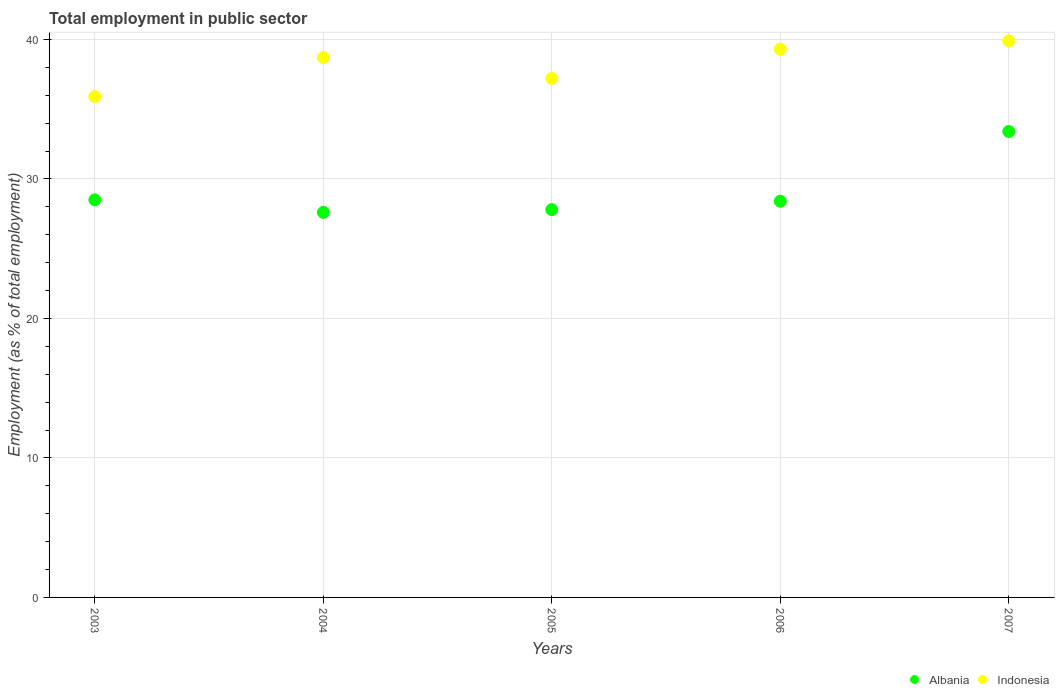What is the employment in public sector in Albania in 2003?
Provide a succinct answer. 28.5. Across all years, what is the maximum employment in public sector in Albania?
Your response must be concise. 33.4. Across all years, what is the minimum employment in public sector in Albania?
Your answer should be compact. 27.6. In which year was the employment in public sector in Albania maximum?
Provide a short and direct response. 2007. In which year was the employment in public sector in Albania minimum?
Provide a short and direct response. 2004. What is the total employment in public sector in Albania in the graph?
Offer a very short reply. 145.7. What is the difference between the employment in public sector in Albania in 2004 and that in 2006?
Make the answer very short. -0.8. What is the difference between the employment in public sector in Indonesia in 2003 and the employment in public sector in Albania in 2005?
Your response must be concise. 8.1. What is the average employment in public sector in Indonesia per year?
Make the answer very short. 38.2. In the year 2003, what is the difference between the employment in public sector in Albania and employment in public sector in Indonesia?
Your response must be concise. -7.4. In how many years, is the employment in public sector in Indonesia greater than 18 %?
Your answer should be very brief. 5. What is the ratio of the employment in public sector in Albania in 2005 to that in 2006?
Offer a very short reply. 0.98. Is the employment in public sector in Albania in 2004 less than that in 2005?
Make the answer very short. Yes. What is the difference between the highest and the second highest employment in public sector in Albania?
Offer a very short reply. 4.9. Does the employment in public sector in Indonesia monotonically increase over the years?
Your answer should be very brief. No. Is the employment in public sector in Albania strictly greater than the employment in public sector in Indonesia over the years?
Provide a succinct answer. No. Is the employment in public sector in Indonesia strictly less than the employment in public sector in Albania over the years?
Your answer should be very brief. No. How many dotlines are there?
Offer a very short reply. 2. How many years are there in the graph?
Provide a succinct answer. 5. Does the graph contain any zero values?
Keep it short and to the point. No. How many legend labels are there?
Make the answer very short. 2. What is the title of the graph?
Offer a very short reply. Total employment in public sector. Does "Least developed countries" appear as one of the legend labels in the graph?
Offer a terse response. No. What is the label or title of the Y-axis?
Your answer should be very brief. Employment (as % of total employment). What is the Employment (as % of total employment) in Indonesia in 2003?
Offer a terse response. 35.9. What is the Employment (as % of total employment) of Albania in 2004?
Your response must be concise. 27.6. What is the Employment (as % of total employment) in Indonesia in 2004?
Provide a succinct answer. 38.7. What is the Employment (as % of total employment) in Albania in 2005?
Offer a terse response. 27.8. What is the Employment (as % of total employment) in Indonesia in 2005?
Keep it short and to the point. 37.2. What is the Employment (as % of total employment) in Albania in 2006?
Your response must be concise. 28.4. What is the Employment (as % of total employment) in Indonesia in 2006?
Offer a very short reply. 39.3. What is the Employment (as % of total employment) in Albania in 2007?
Provide a short and direct response. 33.4. What is the Employment (as % of total employment) in Indonesia in 2007?
Keep it short and to the point. 39.9. Across all years, what is the maximum Employment (as % of total employment) in Albania?
Keep it short and to the point. 33.4. Across all years, what is the maximum Employment (as % of total employment) in Indonesia?
Make the answer very short. 39.9. Across all years, what is the minimum Employment (as % of total employment) of Albania?
Keep it short and to the point. 27.6. Across all years, what is the minimum Employment (as % of total employment) of Indonesia?
Offer a very short reply. 35.9. What is the total Employment (as % of total employment) in Albania in the graph?
Provide a short and direct response. 145.7. What is the total Employment (as % of total employment) of Indonesia in the graph?
Your answer should be compact. 191. What is the difference between the Employment (as % of total employment) in Albania in 2003 and that in 2004?
Provide a succinct answer. 0.9. What is the difference between the Employment (as % of total employment) of Albania in 2003 and that in 2005?
Your answer should be very brief. 0.7. What is the difference between the Employment (as % of total employment) in Albania in 2003 and that in 2006?
Provide a short and direct response. 0.1. What is the difference between the Employment (as % of total employment) of Indonesia in 2003 and that in 2006?
Offer a terse response. -3.4. What is the difference between the Employment (as % of total employment) of Albania in 2003 and that in 2007?
Offer a very short reply. -4.9. What is the difference between the Employment (as % of total employment) of Indonesia in 2003 and that in 2007?
Offer a very short reply. -4. What is the difference between the Employment (as % of total employment) of Indonesia in 2004 and that in 2005?
Provide a succinct answer. 1.5. What is the difference between the Employment (as % of total employment) in Albania in 2004 and that in 2006?
Make the answer very short. -0.8. What is the difference between the Employment (as % of total employment) in Indonesia in 2004 and that in 2007?
Provide a succinct answer. -1.2. What is the difference between the Employment (as % of total employment) in Albania in 2005 and that in 2006?
Provide a succinct answer. -0.6. What is the difference between the Employment (as % of total employment) in Indonesia in 2005 and that in 2006?
Make the answer very short. -2.1. What is the difference between the Employment (as % of total employment) in Albania in 2005 and that in 2007?
Provide a succinct answer. -5.6. What is the difference between the Employment (as % of total employment) in Indonesia in 2005 and that in 2007?
Provide a succinct answer. -2.7. What is the difference between the Employment (as % of total employment) of Albania in 2006 and that in 2007?
Your answer should be compact. -5. What is the difference between the Employment (as % of total employment) in Indonesia in 2006 and that in 2007?
Give a very brief answer. -0.6. What is the difference between the Employment (as % of total employment) in Albania in 2003 and the Employment (as % of total employment) in Indonesia in 2005?
Keep it short and to the point. -8.7. What is the difference between the Employment (as % of total employment) in Albania in 2003 and the Employment (as % of total employment) in Indonesia in 2006?
Your answer should be very brief. -10.8. What is the difference between the Employment (as % of total employment) in Albania in 2003 and the Employment (as % of total employment) in Indonesia in 2007?
Your answer should be very brief. -11.4. What is the difference between the Employment (as % of total employment) in Albania in 2004 and the Employment (as % of total employment) in Indonesia in 2007?
Your response must be concise. -12.3. What is the average Employment (as % of total employment) of Albania per year?
Your response must be concise. 29.14. What is the average Employment (as % of total employment) in Indonesia per year?
Provide a succinct answer. 38.2. In the year 2003, what is the difference between the Employment (as % of total employment) in Albania and Employment (as % of total employment) in Indonesia?
Offer a very short reply. -7.4. In the year 2004, what is the difference between the Employment (as % of total employment) of Albania and Employment (as % of total employment) of Indonesia?
Provide a short and direct response. -11.1. In the year 2005, what is the difference between the Employment (as % of total employment) in Albania and Employment (as % of total employment) in Indonesia?
Make the answer very short. -9.4. In the year 2007, what is the difference between the Employment (as % of total employment) in Albania and Employment (as % of total employment) in Indonesia?
Offer a terse response. -6.5. What is the ratio of the Employment (as % of total employment) of Albania in 2003 to that in 2004?
Your answer should be compact. 1.03. What is the ratio of the Employment (as % of total employment) of Indonesia in 2003 to that in 2004?
Give a very brief answer. 0.93. What is the ratio of the Employment (as % of total employment) in Albania in 2003 to that in 2005?
Your answer should be compact. 1.03. What is the ratio of the Employment (as % of total employment) in Indonesia in 2003 to that in 2005?
Your response must be concise. 0.97. What is the ratio of the Employment (as % of total employment) of Indonesia in 2003 to that in 2006?
Ensure brevity in your answer.  0.91. What is the ratio of the Employment (as % of total employment) of Albania in 2003 to that in 2007?
Your response must be concise. 0.85. What is the ratio of the Employment (as % of total employment) in Indonesia in 2003 to that in 2007?
Your answer should be very brief. 0.9. What is the ratio of the Employment (as % of total employment) of Indonesia in 2004 to that in 2005?
Your response must be concise. 1.04. What is the ratio of the Employment (as % of total employment) of Albania in 2004 to that in 2006?
Your response must be concise. 0.97. What is the ratio of the Employment (as % of total employment) in Indonesia in 2004 to that in 2006?
Provide a short and direct response. 0.98. What is the ratio of the Employment (as % of total employment) in Albania in 2004 to that in 2007?
Make the answer very short. 0.83. What is the ratio of the Employment (as % of total employment) of Indonesia in 2004 to that in 2007?
Provide a succinct answer. 0.97. What is the ratio of the Employment (as % of total employment) in Albania in 2005 to that in 2006?
Your response must be concise. 0.98. What is the ratio of the Employment (as % of total employment) in Indonesia in 2005 to that in 2006?
Ensure brevity in your answer.  0.95. What is the ratio of the Employment (as % of total employment) of Albania in 2005 to that in 2007?
Ensure brevity in your answer.  0.83. What is the ratio of the Employment (as % of total employment) in Indonesia in 2005 to that in 2007?
Offer a very short reply. 0.93. What is the ratio of the Employment (as % of total employment) of Albania in 2006 to that in 2007?
Keep it short and to the point. 0.85. 